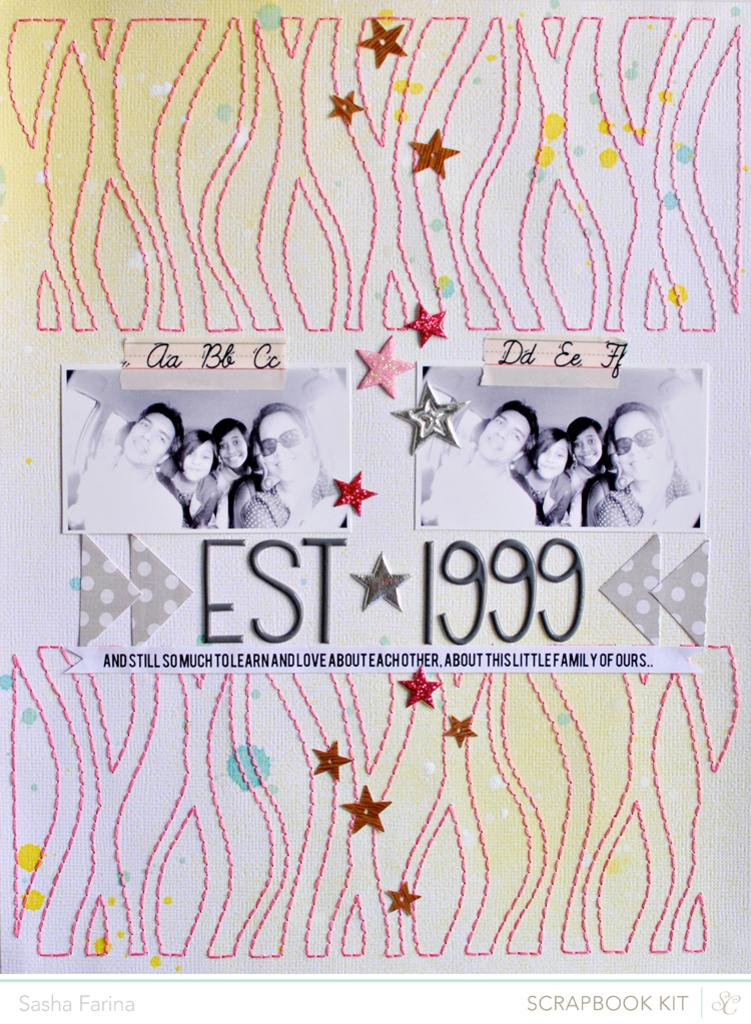What can be seen in the foreground of the image? There are posters, text, stickers, and a thread stitched on a white surface in the foreground of the image. Can you describe the posters in the image? The posters are in the foreground of the image. What type of content is present in the text in the image? The text in the foreground of the image is not described in the provided facts, so we cannot determine its content. What are the stickers in the image used for? The purpose of the stickers in the image is not mentioned in the provided facts. What type of produce is displayed on the calendar in the image? There is no calendar present in the image, so we cannot determine what type of produce might be displayed on it. What type of wool is used to create the thread stitched on the white surface in the image? The type of wool used to create the thread stitched on the white surface in the image is not mentioned in the provided facts. 